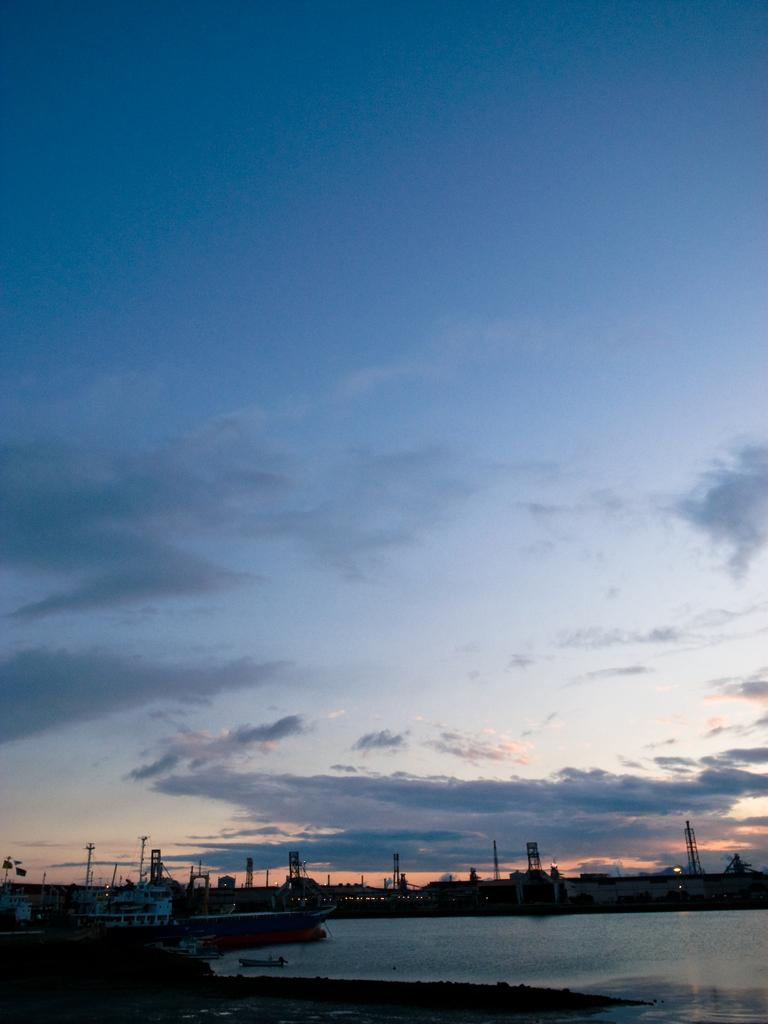What structures are visible in the image? There are many towers in the image. What other objects can be seen in the image? There are poles, ropes, wires, and boats visible in the image. What is at the bottom of the image? There is water at the bottom of the image. What is visible in the sky in the image? The sky is visible in the center of the image, and clouds are present in the sky. What type of soda is being advertised on the boats in the image? There is no soda being advertised on the boats in the image; the boats are simply present in the water. 